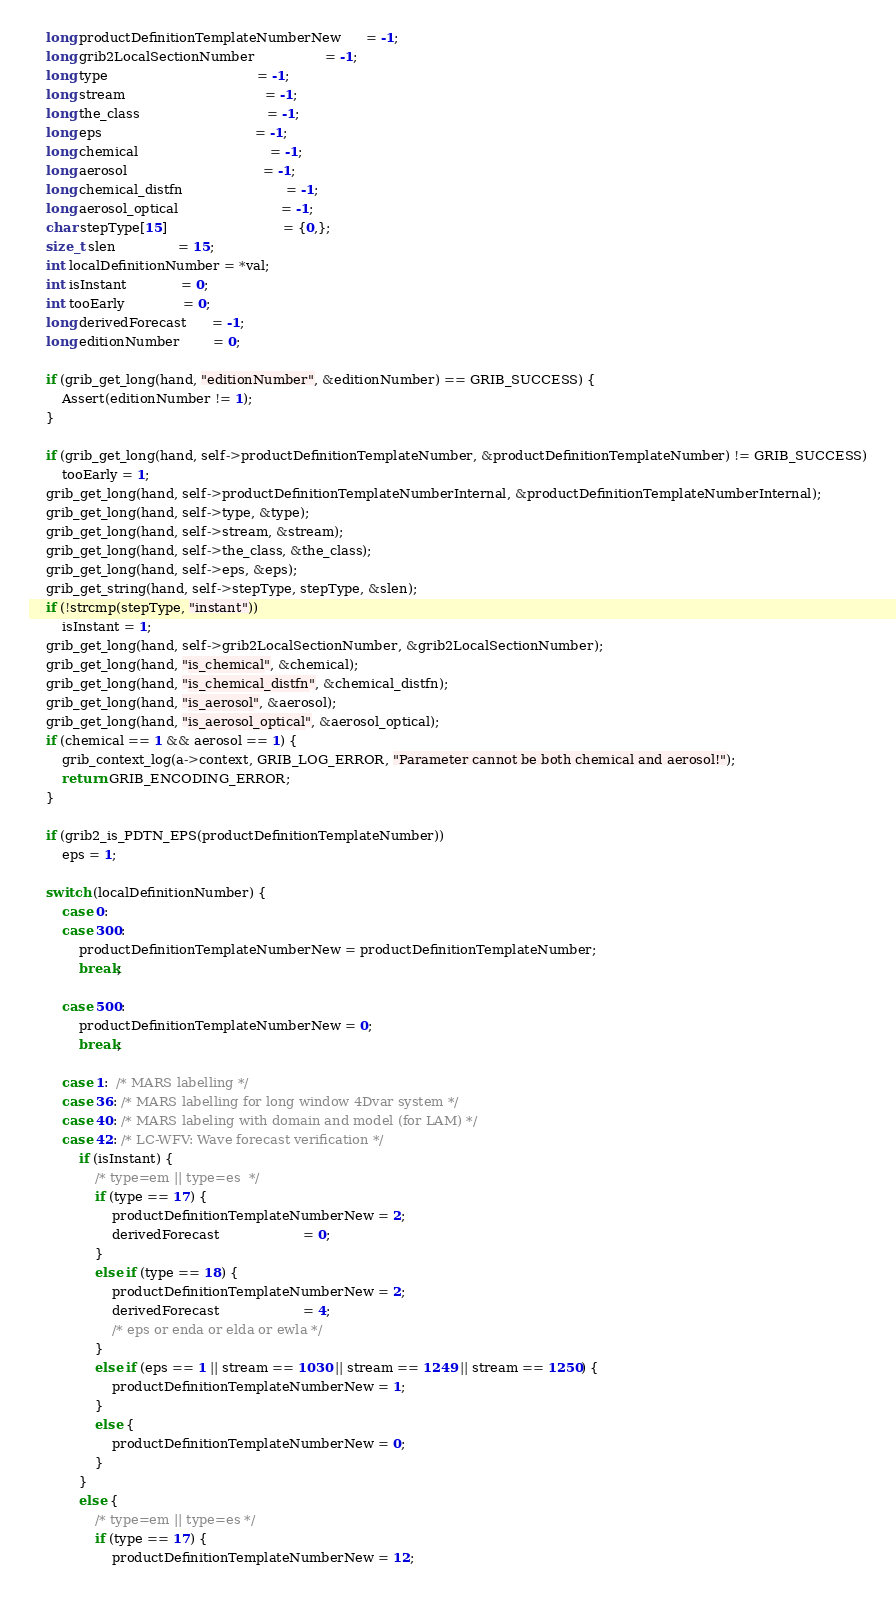<code> <loc_0><loc_0><loc_500><loc_500><_C_>    long productDefinitionTemplateNumberNew      = -1;
    long grib2LocalSectionNumber                 = -1;
    long type                                    = -1;
    long stream                                  = -1;
    long the_class                               = -1;
    long eps                                     = -1;
    long chemical                                = -1;
    long aerosol                                 = -1;
    long chemical_distfn                         = -1;
    long aerosol_optical                         = -1;
    char stepType[15]                            = {0,};
    size_t slen               = 15;
    int localDefinitionNumber = *val;
    int isInstant             = 0;
    int tooEarly              = 0;
    long derivedForecast      = -1;
    long editionNumber        = 0;

    if (grib_get_long(hand, "editionNumber", &editionNumber) == GRIB_SUCCESS) {
        Assert(editionNumber != 1);
    }

    if (grib_get_long(hand, self->productDefinitionTemplateNumber, &productDefinitionTemplateNumber) != GRIB_SUCCESS)
        tooEarly = 1;
    grib_get_long(hand, self->productDefinitionTemplateNumberInternal, &productDefinitionTemplateNumberInternal);
    grib_get_long(hand, self->type, &type);
    grib_get_long(hand, self->stream, &stream);
    grib_get_long(hand, self->the_class, &the_class);
    grib_get_long(hand, self->eps, &eps);
    grib_get_string(hand, self->stepType, stepType, &slen);
    if (!strcmp(stepType, "instant"))
        isInstant = 1;
    grib_get_long(hand, self->grib2LocalSectionNumber, &grib2LocalSectionNumber);
    grib_get_long(hand, "is_chemical", &chemical);
    grib_get_long(hand, "is_chemical_distfn", &chemical_distfn);
    grib_get_long(hand, "is_aerosol", &aerosol);
    grib_get_long(hand, "is_aerosol_optical", &aerosol_optical);
    if (chemical == 1 && aerosol == 1) {
        grib_context_log(a->context, GRIB_LOG_ERROR, "Parameter cannot be both chemical and aerosol!");
        return GRIB_ENCODING_ERROR;
    }

    if (grib2_is_PDTN_EPS(productDefinitionTemplateNumber))
        eps = 1;

    switch (localDefinitionNumber) {
        case 0:
        case 300:
            productDefinitionTemplateNumberNew = productDefinitionTemplateNumber;
            break;

        case 500:
            productDefinitionTemplateNumberNew = 0;
            break;

        case 1:  /* MARS labelling */
        case 36: /* MARS labelling for long window 4Dvar system */
        case 40: /* MARS labeling with domain and model (for LAM) */
        case 42: /* LC-WFV: Wave forecast verification */
            if (isInstant) {
                /* type=em || type=es  */
                if (type == 17) {
                    productDefinitionTemplateNumberNew = 2;
                    derivedForecast                    = 0;
                }
                else if (type == 18) {
                    productDefinitionTemplateNumberNew = 2;
                    derivedForecast                    = 4;
                    /* eps or enda or elda or ewla */
                }
                else if (eps == 1 || stream == 1030 || stream == 1249 || stream == 1250) {
                    productDefinitionTemplateNumberNew = 1;
                }
                else {
                    productDefinitionTemplateNumberNew = 0;
                }
            }
            else {
                /* type=em || type=es */
                if (type == 17) {
                    productDefinitionTemplateNumberNew = 12;</code> 